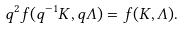Convert formula to latex. <formula><loc_0><loc_0><loc_500><loc_500>q ^ { 2 } f ( q ^ { - 1 } K , q { \mathit \Lambda } ) = f ( K , { \mathit \Lambda } ) .</formula> 